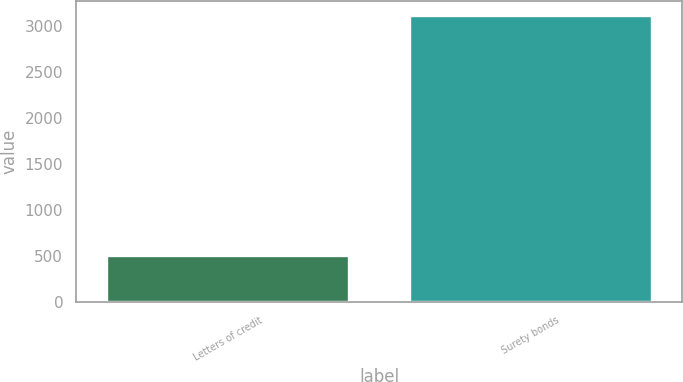Convert chart. <chart><loc_0><loc_0><loc_500><loc_500><bar_chart><fcel>Letters of credit<fcel>Surety bonds<nl><fcel>503.4<fcel>3109.3<nl></chart> 